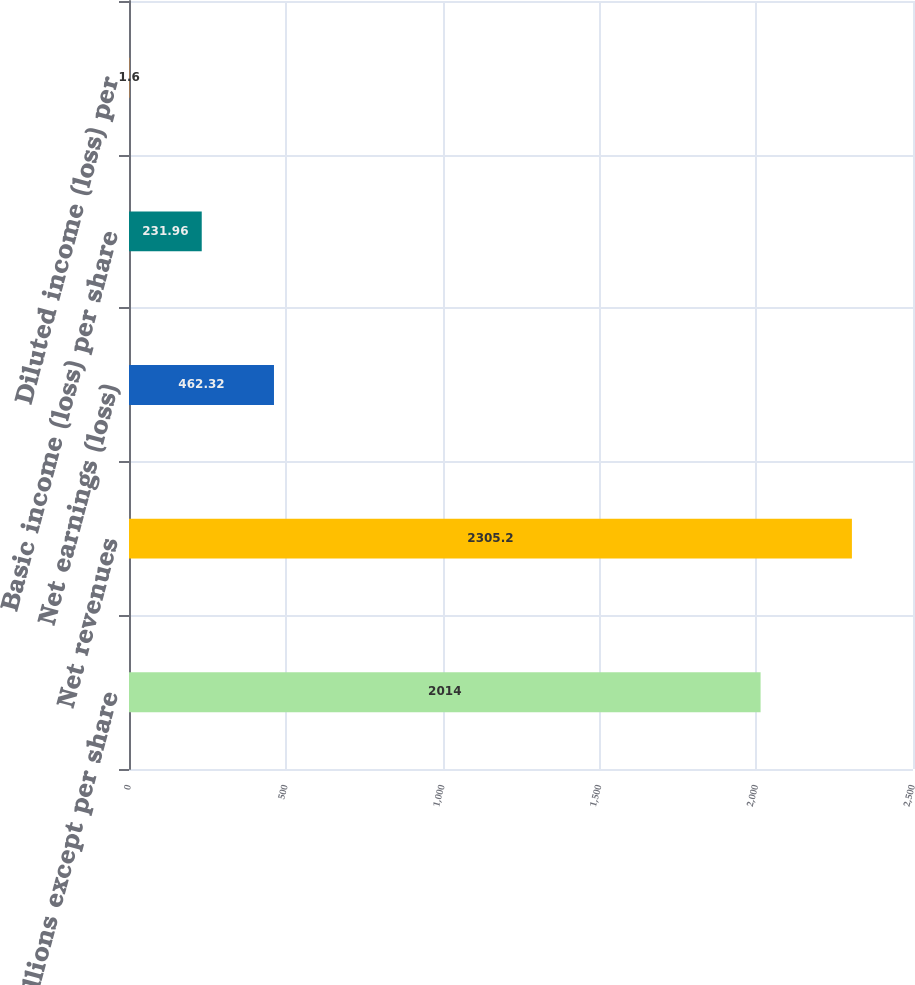Convert chart. <chart><loc_0><loc_0><loc_500><loc_500><bar_chart><fcel>In millions except per share<fcel>Net revenues<fcel>Net earnings (loss)<fcel>Basic income (loss) per share<fcel>Diluted income (loss) per<nl><fcel>2014<fcel>2305.2<fcel>462.32<fcel>231.96<fcel>1.6<nl></chart> 